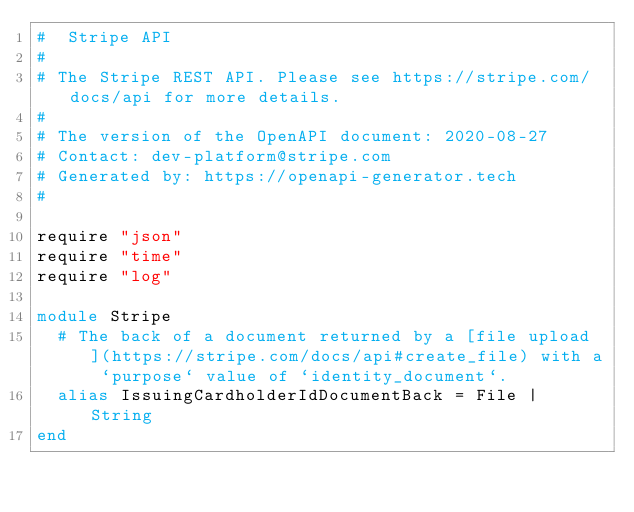Convert code to text. <code><loc_0><loc_0><loc_500><loc_500><_Crystal_>#  Stripe API
#
# The Stripe REST API. Please see https://stripe.com/docs/api for more details.
#
# The version of the OpenAPI document: 2020-08-27
# Contact: dev-platform@stripe.com
# Generated by: https://openapi-generator.tech
#

require "json"
require "time"
require "log"

module Stripe
  # The back of a document returned by a [file upload](https://stripe.com/docs/api#create_file) with a `purpose` value of `identity_document`.
  alias IssuingCardholderIdDocumentBack = File | String
end
</code> 